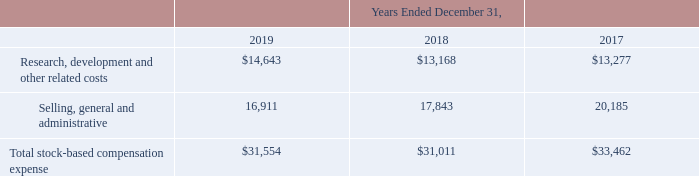Stock-based Compensation Expense
The following table sets forth our stock-based compensation expense for the years ended December 31, 2019, 2018 and 2017 (in thousands):
Stock-based compensation awards include employee stock options, restricted stock awards and units, and employee stock purchases. For the year ended December 31, 2019, stock-based compensation expense was $31.6 million, of which $0.2 million related to employee stock options, $29.1 million related to restricted stock awards and units and $2.3 million related to employee stock purchases. For the year ended December 31, 2018, stock-based compensation expense was $31.0 million, of which $0.4 million related to employee stock options, $28.0 million related to restricted stock awards and units and $2.6 million related to employee stock purchases. The increase in stock-based compensation expense in 2019 compared to 2018 was due primarily to a higher volume of restricted stock unit grants.
What is included in stock-based compensation awards? Employee stock options, restricted stock awards and units, and employee stock purchases. What were the stock-based compensation expenses for the year ended December 31, 2018, and 2019, respectively? $31.0 million, $31.6 million. What caused the increment in stock-based compensation expense in 2019 compared to 2018? A higher volume of restricted stock unit grants. What is the overall proportion of employee stock options and employee stock purchases over total stock-based compensation expense in 2019? (0.2+2.3)/31.6 
Answer: 0.08. What is the percentage change in total stock-based compensation expense in 2018 compared to 2017?
Answer scale should be: percent. (31,011-33,462)/33,462 
Answer: -7.32. What is the total stock-based compensation expense related to research, development, and other related costs from 2017 to 2019?
Answer scale should be: thousand. 14,643+13,168+13,277 
Answer: 41088. 